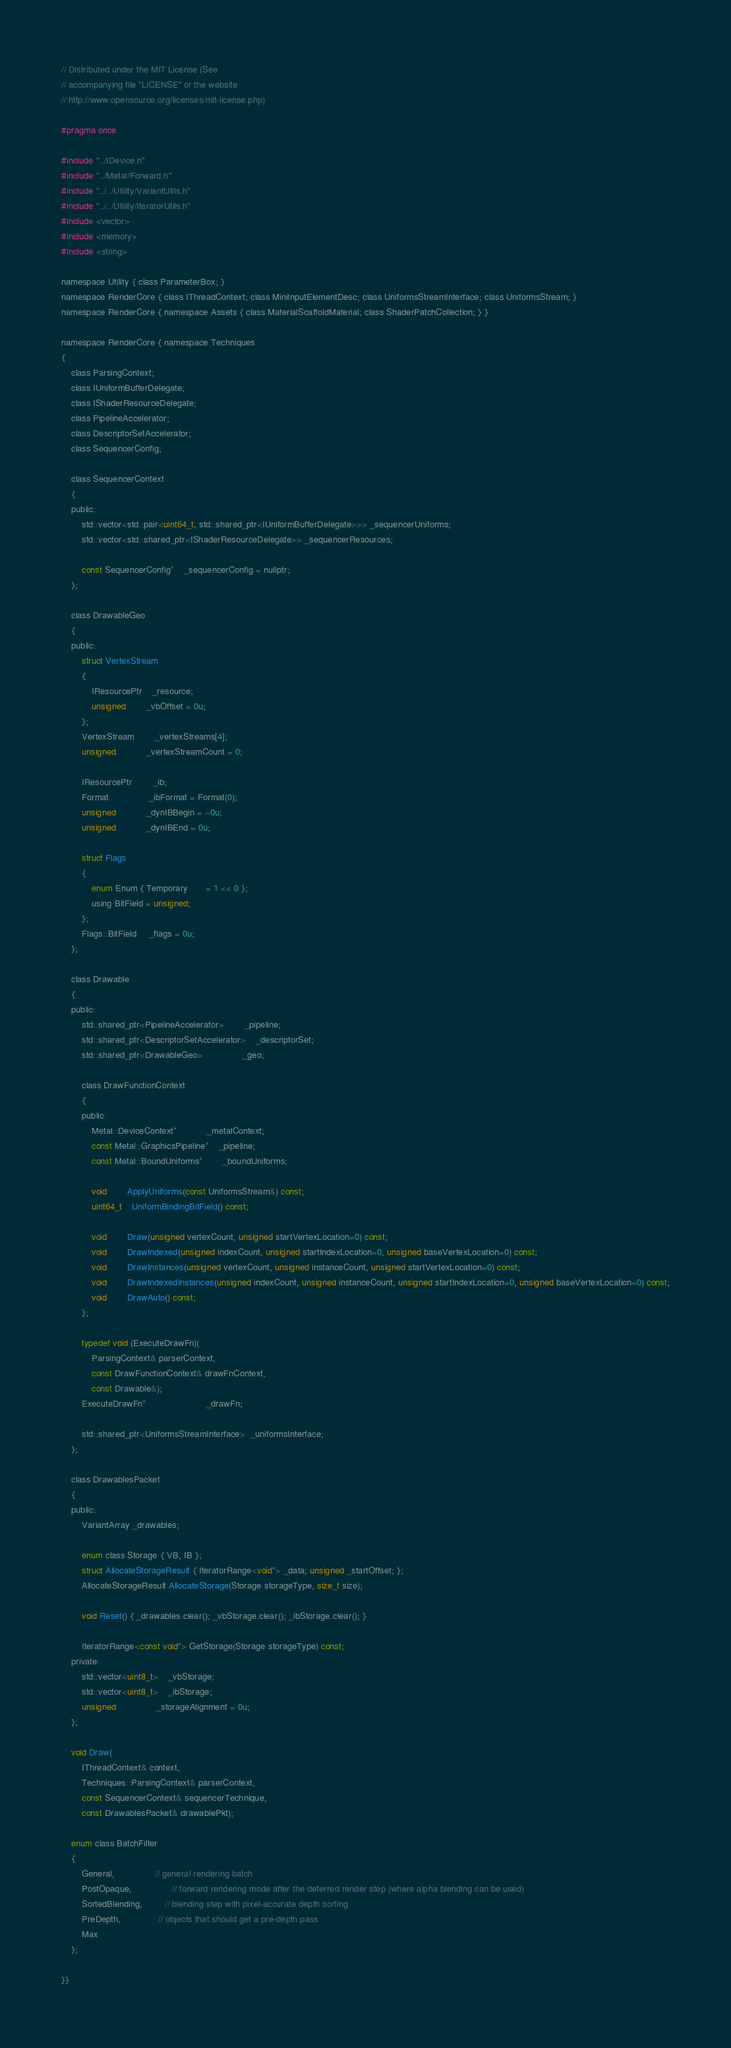<code> <loc_0><loc_0><loc_500><loc_500><_C_>// Distributed under the MIT License (See
// accompanying file "LICENSE" or the website
// http://www.opensource.org/licenses/mit-license.php)

#pragma once

#include "../IDevice.h"
#include "../Metal/Forward.h"
#include "../../Utility/VariantUtils.h"
#include "../../Utility/IteratorUtils.h"
#include <vector>
#include <memory>
#include <string>

namespace Utility { class ParameterBox; }
namespace RenderCore { class IThreadContext; class MiniInputElementDesc; class UniformsStreamInterface; class UniformsStream; }
namespace RenderCore { namespace Assets { class MaterialScaffoldMaterial; class ShaderPatchCollection; } }

namespace RenderCore { namespace Techniques
{
	class ParsingContext;
	class IUniformBufferDelegate;
	class IShaderResourceDelegate;
	class PipelineAccelerator;
	class DescriptorSetAccelerator;
	class SequencerConfig;

	class SequencerContext
	{
	public:
		std::vector<std::pair<uint64_t, std::shared_ptr<IUniformBufferDelegate>>> _sequencerUniforms;
		std::vector<std::shared_ptr<IShaderResourceDelegate>> _sequencerResources;

		const SequencerConfig*	_sequencerConfig = nullptr;
	};

	class DrawableGeo
    {
    public:
        struct VertexStream
        {
            IResourcePtr	_resource;
            unsigned		_vbOffset = 0u;
        };
        VertexStream        _vertexStreams[4];
        unsigned            _vertexStreamCount = 0;

        IResourcePtr		_ib;
        Format				_ibFormat = Format(0);
        unsigned			_dynIBBegin = ~0u;
        unsigned			_dynIBEnd = 0u;

        struct Flags
        {
            enum Enum { Temporary       = 1 << 0 };
            using BitField = unsigned;
        };
        Flags::BitField     _flags = 0u;
    };

	class Drawable
	{
	public:
        std::shared_ptr<PipelineAccelerator>		_pipeline;
		std::shared_ptr<DescriptorSetAccelerator>	_descriptorSet;
        std::shared_ptr<DrawableGeo>				_geo;

		class DrawFunctionContext
		{
		public:
			Metal::DeviceContext*			_metalContext;
			const Metal::GraphicsPipeline*	_pipeline;
			const Metal::BoundUniforms*		_boundUniforms;

			void		ApplyUniforms(const UniformsStream&) const;
			uint64_t	UniformBindingBitField() const;

			void        Draw(unsigned vertexCount, unsigned startVertexLocation=0) const;
			void        DrawIndexed(unsigned indexCount, unsigned startIndexLocation=0, unsigned baseVertexLocation=0) const;
			void		DrawInstances(unsigned vertexCount, unsigned instanceCount, unsigned startVertexLocation=0) const;
			void		DrawIndexedInstances(unsigned indexCount, unsigned instanceCount, unsigned startIndexLocation=0, unsigned baseVertexLocation=0) const;
			void        DrawAuto() const;
		};

        typedef void (ExecuteDrawFn)(
			ParsingContext& parserContext,
			const DrawFunctionContext& drawFnContext,
            const Drawable&);
        ExecuteDrawFn*						_drawFn;

        std::shared_ptr<UniformsStreamInterface>  _uniformsInterface;
	};

	class DrawablesPacket
	{
	public:
		VariantArray _drawables;

		enum class Storage { VB, IB };
		struct AllocateStorageResult { IteratorRange<void*> _data; unsigned _startOffset; };
		AllocateStorageResult AllocateStorage(Storage storageType, size_t size);

		void Reset() { _drawables.clear(); _vbStorage.clear(); _ibStorage.clear(); }

		IteratorRange<const void*> GetStorage(Storage storageType) const;
	private:
		std::vector<uint8_t>	_vbStorage;
		std::vector<uint8_t>	_ibStorage;
		unsigned				_storageAlignment = 0u;
	};

	void Draw(
		IThreadContext& context,
        Techniques::ParsingContext& parserContext,
		const SequencerContext& sequencerTechnique,
		const DrawablesPacket& drawablePkt);

	enum class BatchFilter
    {
        General,                // general rendering batch
        PostOpaque,				// forward rendering mode after the deferred render step (where alpha blending can be used)
        SortedBlending,         // blending step with pixel-accurate depth sorting
		PreDepth,               // objects that should get a pre-depth pass
		Max
    };

}}</code> 